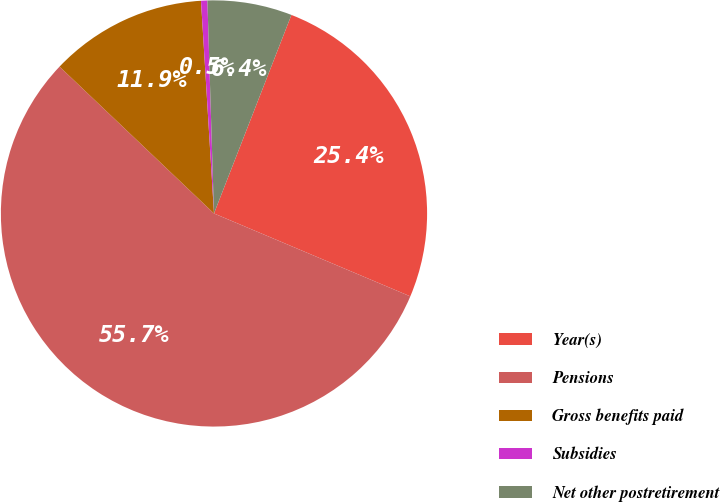Convert chart. <chart><loc_0><loc_0><loc_500><loc_500><pie_chart><fcel>Year(s)<fcel>Pensions<fcel>Gross benefits paid<fcel>Subsidies<fcel>Net other postretirement<nl><fcel>25.44%<fcel>55.74%<fcel>11.93%<fcel>0.48%<fcel>6.41%<nl></chart> 